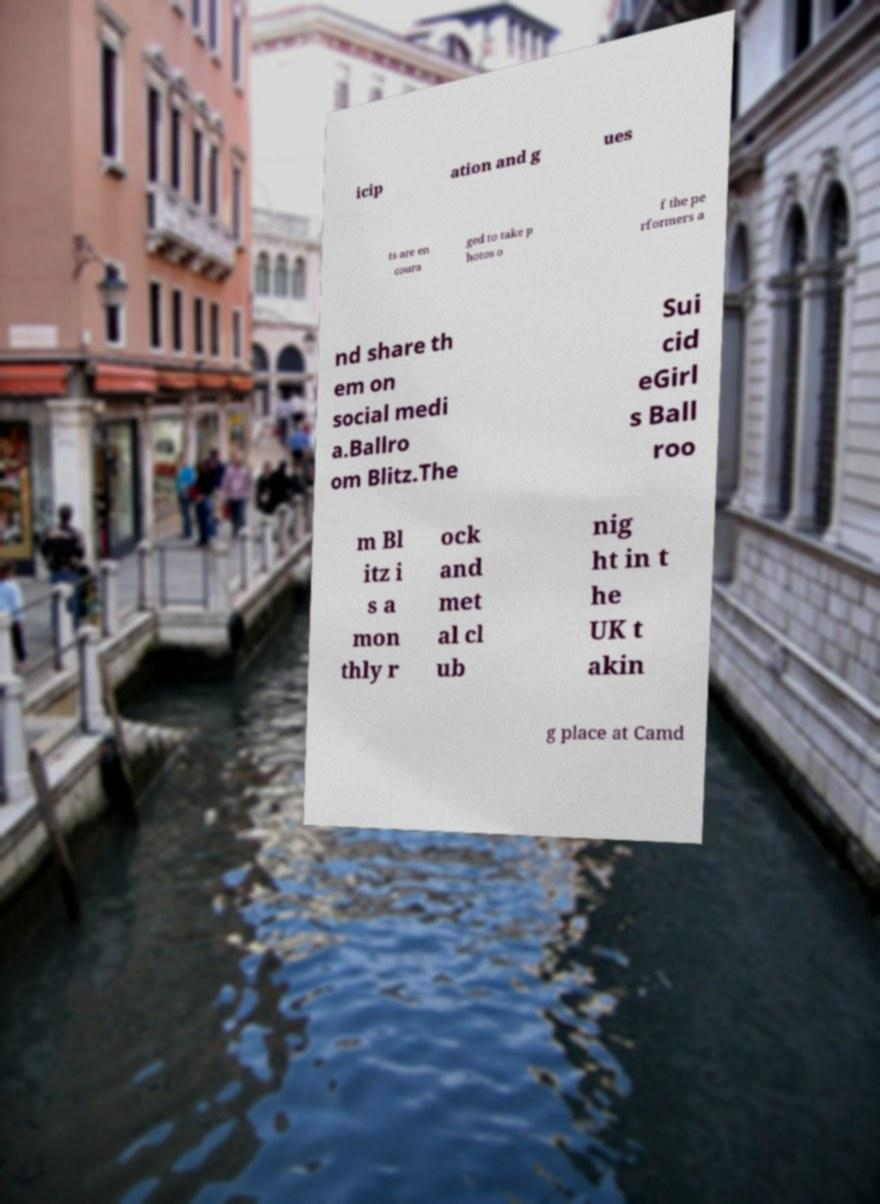Could you assist in decoding the text presented in this image and type it out clearly? icip ation and g ues ts are en coura ged to take p hotos o f the pe rformers a nd share th em on social medi a.Ballro om Blitz.The Sui cid eGirl s Ball roo m Bl itz i s a mon thly r ock and met al cl ub nig ht in t he UK t akin g place at Camd 